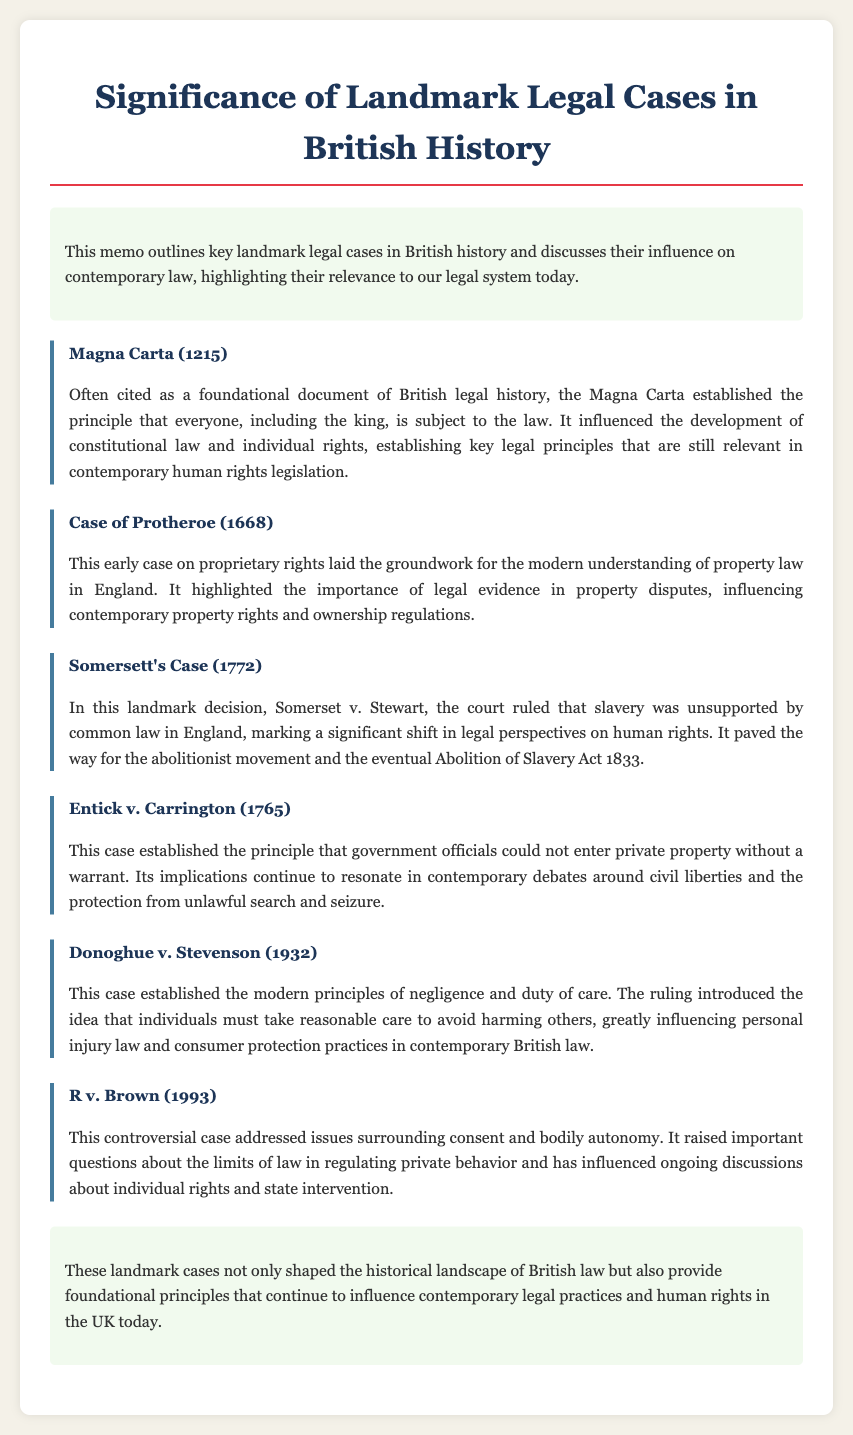What is considered the foundational document of British legal history? The document states that the Magna Carta is often cited as the foundational document of British legal history.
Answer: Magna Carta In what year did the Magna Carta get established? The document specifies that the Magna Carta was established in 1215.
Answer: 1215 What principle did Entick v. Carrington (1765) establish? According to the document, this case established the principle that government officials could not enter private property without a warrant.
Answer: Government officials cannot enter private property without a warrant What case influenced the abolitionist movement? The memo highlights that Somerset v. Stewart, also known as Somersett's Case, marked a significant shift in legal perspectives on human rights and influenced the abolitionist movement.
Answer: Somersett's Case What significant legal principle did Donoghue v. Stevenson (1932) introduce? The case is noted for establishing the modern principles of negligence and duty of care.
Answer: Negligence and duty of care How many landmark cases are discussed in the document? The memo mentions six landmark cases in total.
Answer: Six What does the conclusion of the memo emphasize? The conclusion states that landmark cases shaped historical British law and continue to influence contemporary legal practices and human rights.
Answer: Influence on contemporary legal practices and human rights What overarching theme do these landmark cases illustrate? The document explains that these cases provide foundational principles that influence contemporary legal practices.
Answer: Foundational principles 